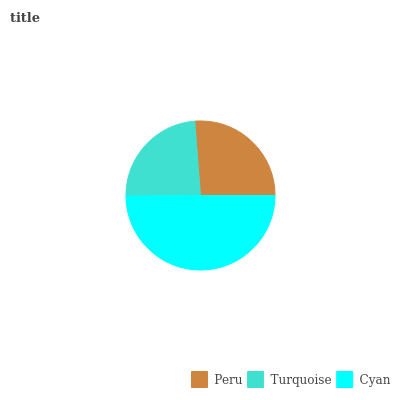Is Turquoise the minimum?
Answer yes or no. Yes. Is Cyan the maximum?
Answer yes or no. Yes. Is Cyan the minimum?
Answer yes or no. No. Is Turquoise the maximum?
Answer yes or no. No. Is Cyan greater than Turquoise?
Answer yes or no. Yes. Is Turquoise less than Cyan?
Answer yes or no. Yes. Is Turquoise greater than Cyan?
Answer yes or no. No. Is Cyan less than Turquoise?
Answer yes or no. No. Is Peru the high median?
Answer yes or no. Yes. Is Peru the low median?
Answer yes or no. Yes. Is Cyan the high median?
Answer yes or no. No. Is Turquoise the low median?
Answer yes or no. No. 